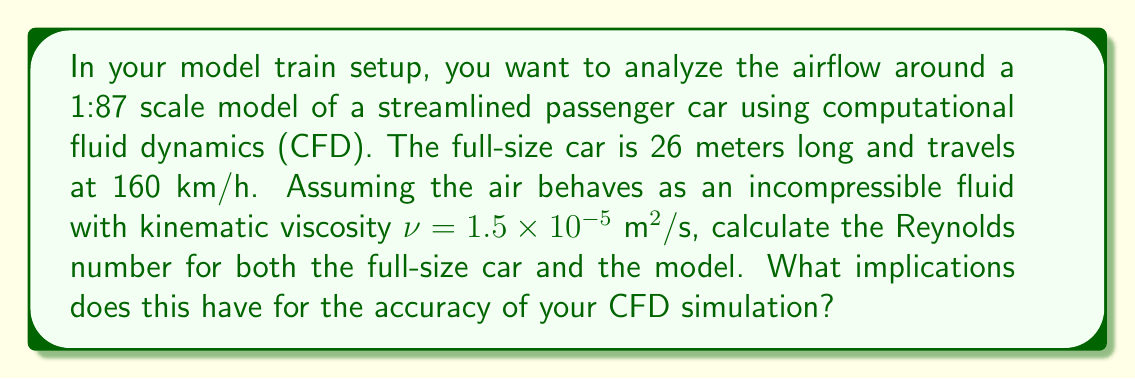Show me your answer to this math problem. To solve this problem, we'll follow these steps:

1) Calculate the Reynolds number for the full-size car
2) Calculate the Reynolds number for the model car
3) Compare the two and discuss implications

The Reynolds number is given by the formula:

$$ Re = \frac{UL}{\nu} $$

Where:
$U$ is the velocity
$L$ is the characteristic length (in this case, the length of the car)
$\nu$ is the kinematic viscosity of air

For the full-size car:
$U = 160 \text{ km/h} = 44.44 \text{ m/s}$
$L = 26 \text{ m}$
$\nu = 1.5 \times 10^{-5} \text{ m}^2/\text{s}$

$$ Re_{\text{full}} = \frac{44.44 \times 26}{1.5 \times 10^{-5}} = 7.70 \times 10^7 $$

For the model car:
The scale is 1:87, so the model length is $L_{\text{model}} = 26 / 87 = 0.299 \text{ m}$
To maintain dynamic similarity, we need to keep the Reynolds number the same. This would require a velocity of:

$$ U_{\text{model}} = \frac{Re_{\text{full}} \times \nu}{L_{\text{model}}} = \frac{7.70 \times 10^7 \times 1.5 \times 10^{-5}}{0.299} = 3,866 \text{ m/s} $$

This velocity is not achievable in a realistic model setup. Let's assume you're simulating the model at the same relative speed as the full-size car:

$U_{\text{model}} = 160 / 87 = 1.84 \text{ m/s}$

Now we can calculate the Reynolds number for the model:

$$ Re_{\text{model}} = \frac{1.84 \times 0.299}{1.5 \times 10^{-5}} = 3.67 \times 10^4 $$

The significant difference in Reynolds numbers (7.70 × 10^7 vs 3.67 × 10^4) implies that the flow regimes are different. The full-size car experiences fully turbulent flow, while the model may experience transitional or even laminar flow in some regions. This discrepancy means that the CFD simulation of the model may not accurately represent the airflow around the full-size car, particularly in areas of separation, wake formation, and boundary layer behavior.
Answer: Full-size car Reynolds number: $7.70 \times 10^7$
Model car Reynolds number: $3.67 \times 10^4$

The large difference in Reynolds numbers implies that the CFD simulation of the model may not accurately represent the airflow around the full-size car, particularly in turbulent flow regions. 